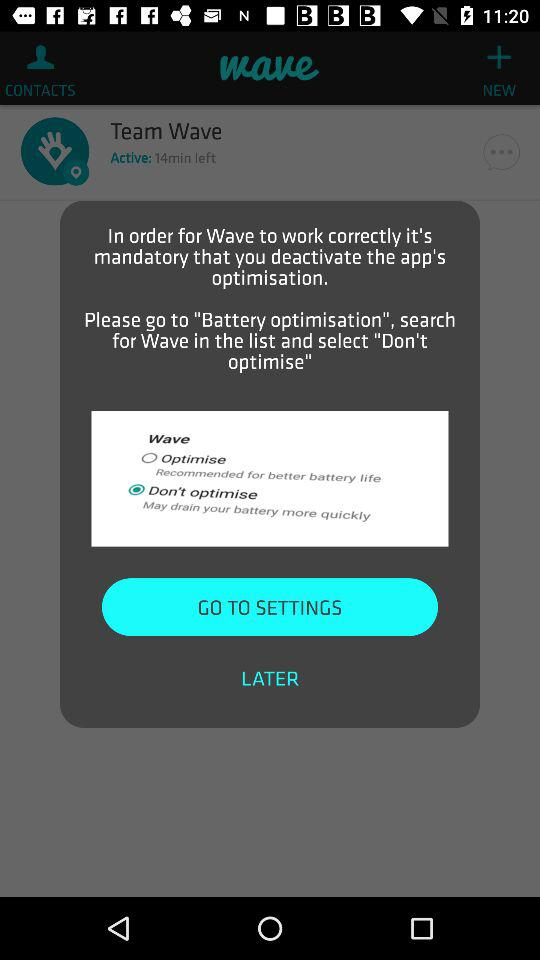How many phrases are there that are not warnings?
Answer the question using a single word or phrase. 2 